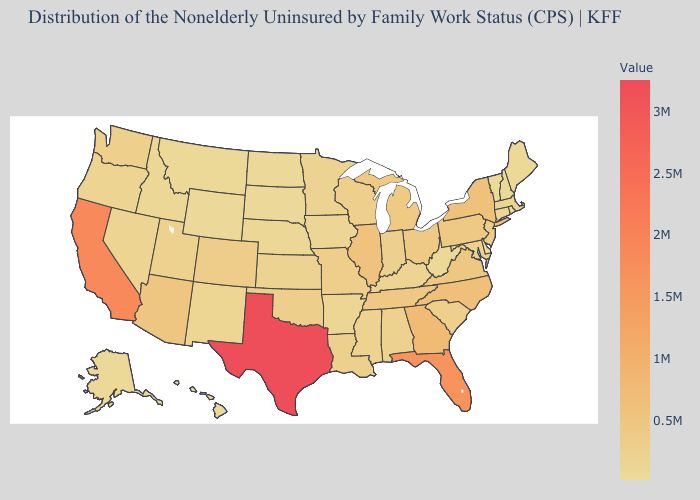Does Georgia have the highest value in the South?
Quick response, please. No. Which states have the lowest value in the West?
Be succinct. Hawaii. Is the legend a continuous bar?
Answer briefly. Yes. Among the states that border Utah , does Arizona have the highest value?
Write a very short answer. Yes. Among the states that border Vermont , which have the highest value?
Concise answer only. New York. Which states have the lowest value in the South?
Give a very brief answer. Delaware. 